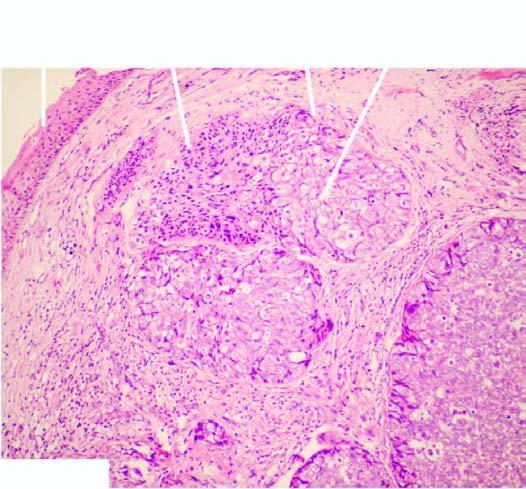re the tumour cells arranged as lobules with peripheral basaloid cells and pale cells in the centre?
Answer the question using a single word or phrase. Yes 